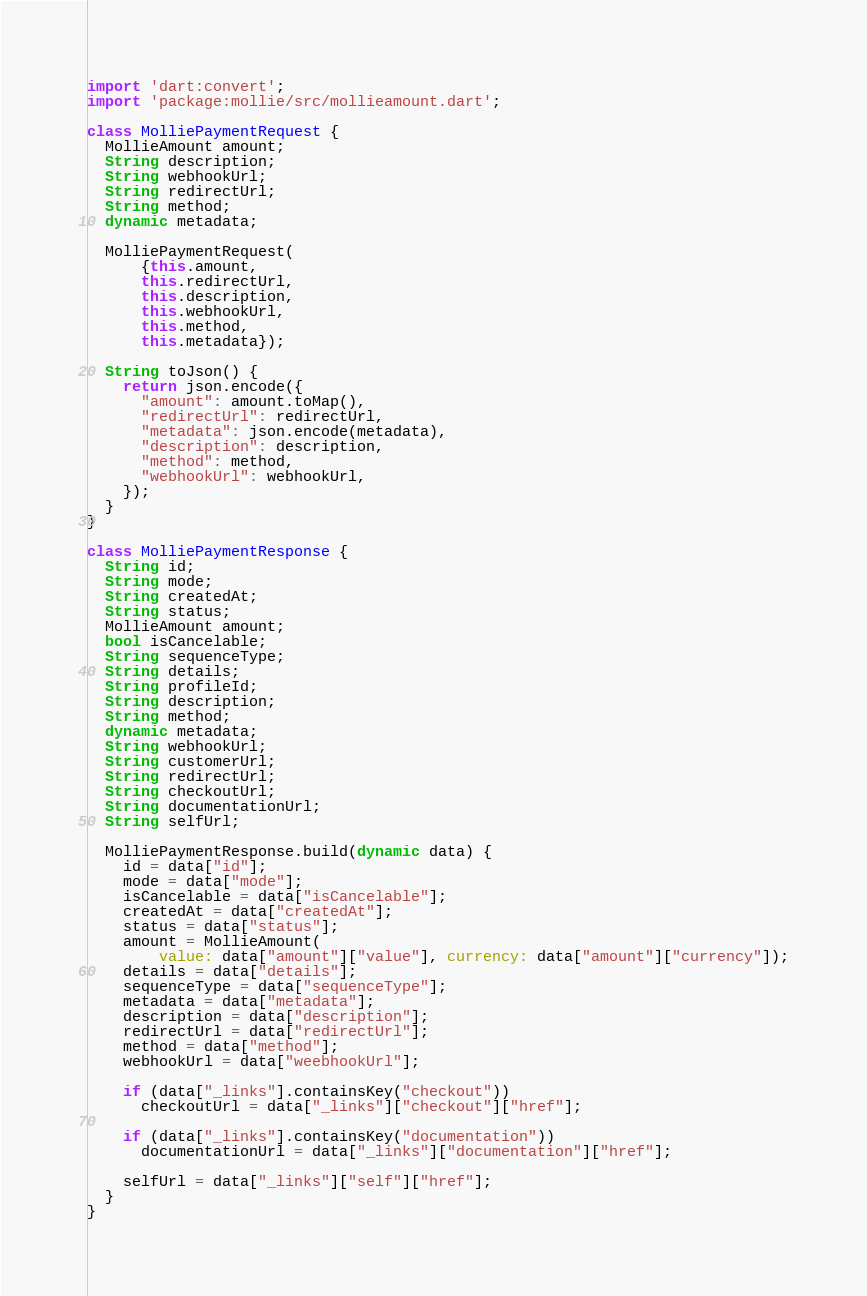Convert code to text. <code><loc_0><loc_0><loc_500><loc_500><_Dart_>import 'dart:convert';
import 'package:mollie/src/mollieamount.dart';

class MolliePaymentRequest {
  MollieAmount amount;
  String description;
  String webhookUrl;
  String redirectUrl;
  String method;
  dynamic metadata;

  MolliePaymentRequest(
      {this.amount,
      this.redirectUrl,
      this.description,
      this.webhookUrl,
      this.method,
      this.metadata});

  String toJson() {
    return json.encode({
      "amount": amount.toMap(),
      "redirectUrl": redirectUrl,
      "metadata": json.encode(metadata),
      "description": description,
      "method": method,
      "webhookUrl": webhookUrl,
    });
  }
}

class MolliePaymentResponse {
  String id;
  String mode;
  String createdAt;
  String status;
  MollieAmount amount;
  bool isCancelable;
  String sequenceType;
  String details;
  String profileId;
  String description;
  String method;
  dynamic metadata;
  String webhookUrl;
  String customerUrl;
  String redirectUrl;
  String checkoutUrl;
  String documentationUrl;
  String selfUrl;

  MolliePaymentResponse.build(dynamic data) {
    id = data["id"];
    mode = data["mode"];
    isCancelable = data["isCancelable"];
    createdAt = data["createdAt"];
    status = data["status"];
    amount = MollieAmount(
        value: data["amount"]["value"], currency: data["amount"]["currency"]);
    details = data["details"];
    sequenceType = data["sequenceType"];
    metadata = data["metadata"];
    description = data["description"];
    redirectUrl = data["redirectUrl"];
    method = data["method"];
    webhookUrl = data["weebhookUrl"];

    if (data["_links"].containsKey("checkout"))
      checkoutUrl = data["_links"]["checkout"]["href"];

    if (data["_links"].containsKey("documentation"))
      documentationUrl = data["_links"]["documentation"]["href"];

    selfUrl = data["_links"]["self"]["href"];
  }
}
</code> 